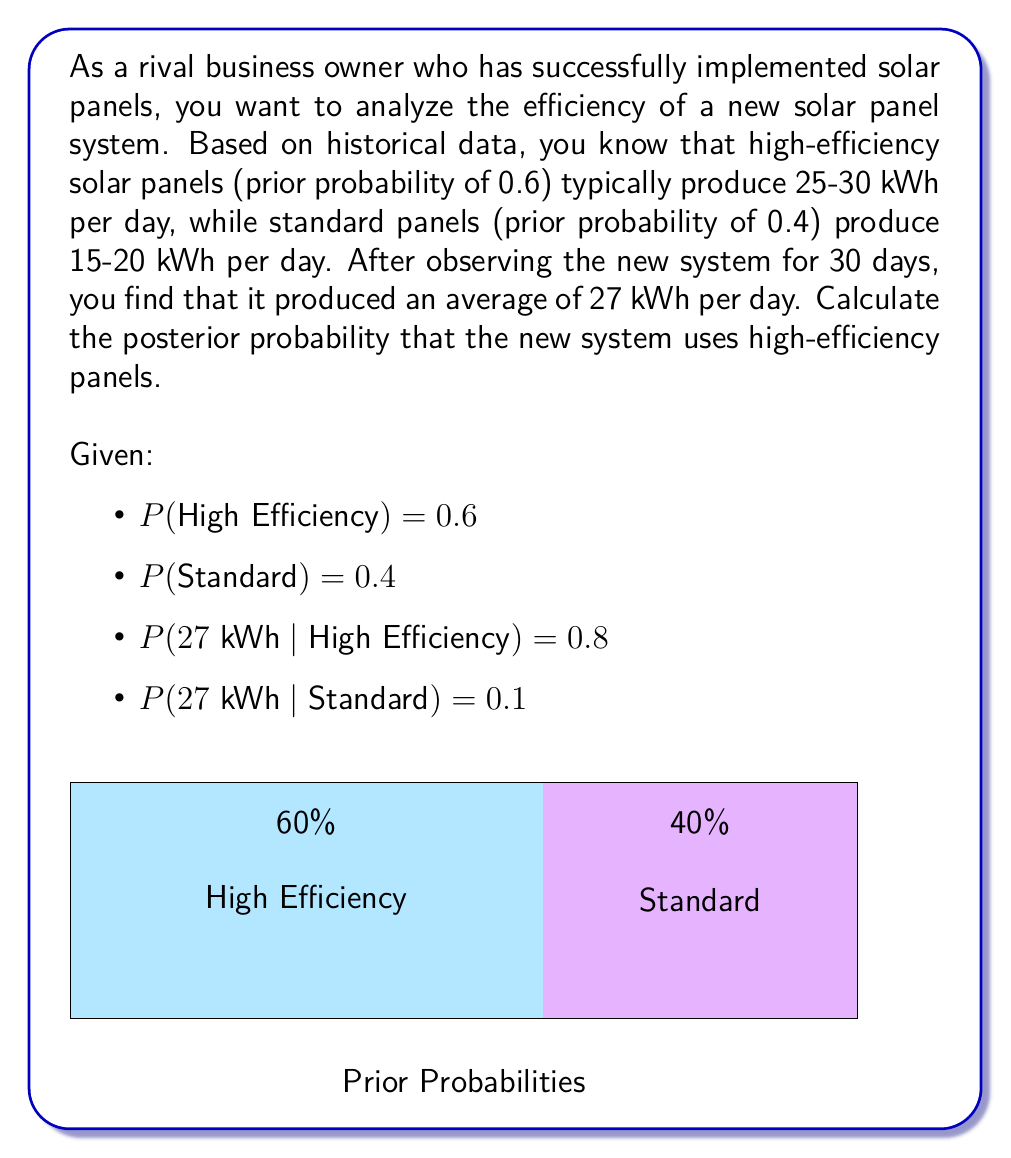Give your solution to this math problem. To solve this problem, we'll use Bayes' theorem:

$$ P(A|B) = \frac{P(B|A) \cdot P(A)}{P(B)} $$

Where:
A = High Efficiency panels
B = Observed 27 kWh per day

Step 1: Identify the given probabilities
- P(A) = P(High Efficiency) = 0.6
- P(not A) = P(Standard) = 0.4
- P(B|A) = P(27 kWh | High Efficiency) = 0.8
- P(B|not A) = P(27 kWh | Standard) = 0.1

Step 2: Calculate P(B) using the law of total probability
$$ P(B) = P(B|A) \cdot P(A) + P(B|not A) \cdot P(not A) $$
$$ P(B) = 0.8 \cdot 0.6 + 0.1 \cdot 0.4 = 0.48 + 0.04 = 0.52 $$

Step 3: Apply Bayes' theorem
$$ P(A|B) = \frac{P(B|A) \cdot P(A)}{P(B)} $$
$$ P(A|B) = \frac{0.8 \cdot 0.6}{0.52} = \frac{0.48}{0.52} \approx 0.9231 $$

Step 4: Convert to percentage
0.9231 * 100% ≈ 92.31%
Answer: 92.31% 